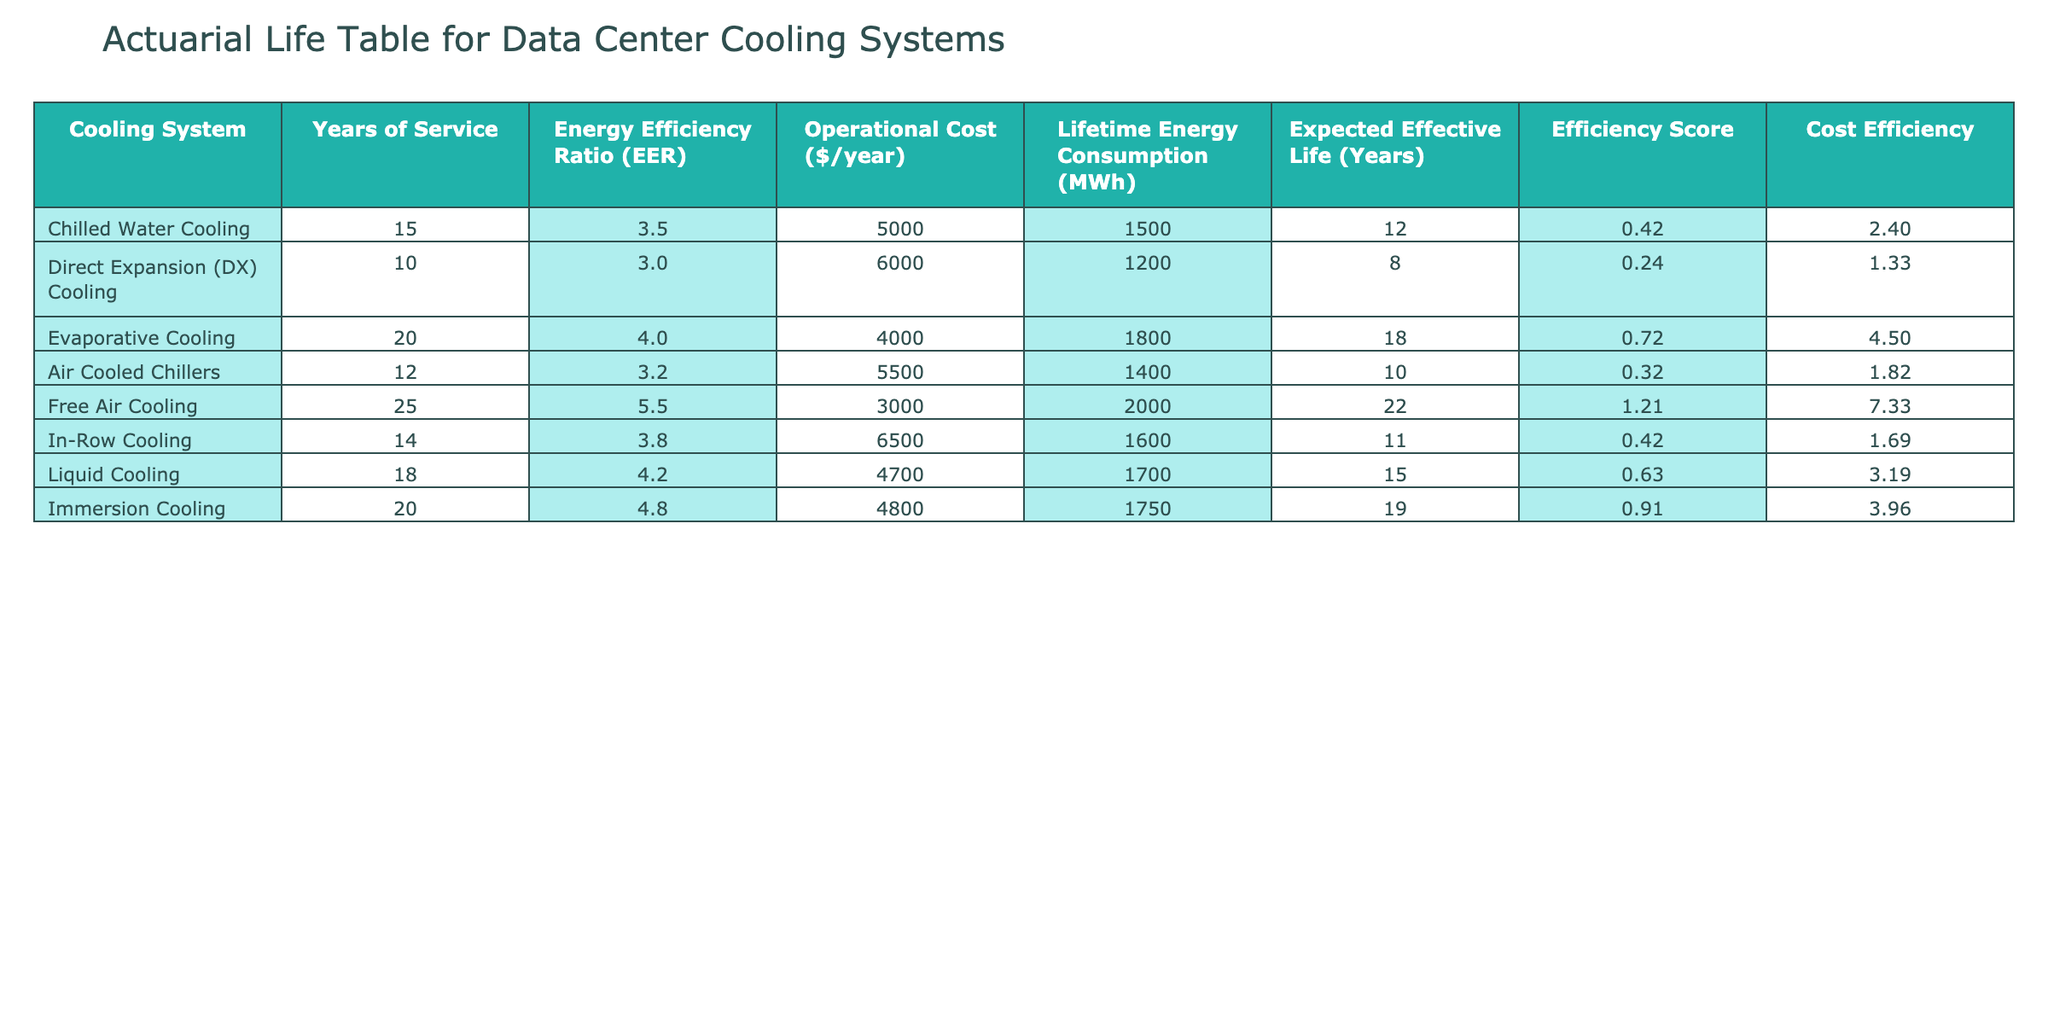What is the Energy Efficiency Ratio (EER) of Free Air Cooling? The table lists Free Air Cooling with an Energy Efficiency Ratio (EER) of 5.5. This value can be directly located under the "Energy Efficiency Ratio (EER)" column for the Free Air Cooling row.
Answer: 5.5 Which cooling system has the lowest operational cost per year? By inspecting the "Operational Cost ($/year)" column, it can be observed that Free Air Cooling has the lowest operational cost at $3000 per year compared to other systems listed.
Answer: Free Air Cooling Calculate the average Expected Effective Life of all cooling systems. To find the average Expected Effective Life, first, sum the values: 12 + 8 + 18 + 10 + 22 + 11 + 15 + 19 = 125. There are 8 systems, so the average is 125 / 8 = 15.625, which can be rounded to 15.6 years.
Answer: 15.6 Is the Lifetime Energy Consumption for Immersion Cooling greater than that for Direct Expansion Cooling? The Lifetime Energy Consumption for Immersion Cooling is 1750 MWh, while for Direct Expansion Cooling it is 1200 MWh. Since 1750 is greater than 1200, the answer is yes.
Answer: Yes What is the difference in Lifecycle Expectancy (Expected Effective Life) between the system with the longest life and the system with the shortest life? Free Air Cooling has the longest Expected Effective Life at 22 years and Direct Expansion Cooling has the shortest at 8 years. The difference is 22 - 8 = 14 years.
Answer: 14 Which cooling system has the best Efficiency Score? Efficiency Score is calculated as Energy Efficiency Ratio (EER) multiplied by Expected Effective Life (Years) divided by 100. The highest Efficiency Score is for Free Air Cooling: 5.5 * 22 / 100 = 1.21. Even if we calculate other systems, Free Air Cooling will have the maximum score.
Answer: Free Air Cooling Does Air Cooled Chillers have a higher Energy Efficiency Ratio (EER) than Direct Expansion Cooling? Air Cooled Chillers has an EER of 3.2 while Direct Expansion Cooling has an EER of 3.0. Since 3.2 is greater than 3.0, the answer is yes.
Answer: Yes If a data center decides to switch from Direct Expansion Cooling to Immersion Cooling, how much will it save in operational costs per year? Direct Expansion Cooling has an operational cost of $6000 per year and Immersion Cooling has $4800 per year. The difference in operational costs is 6000 - 4800 = 1200, indicating a saving of $1200 per year.
Answer: 1200 